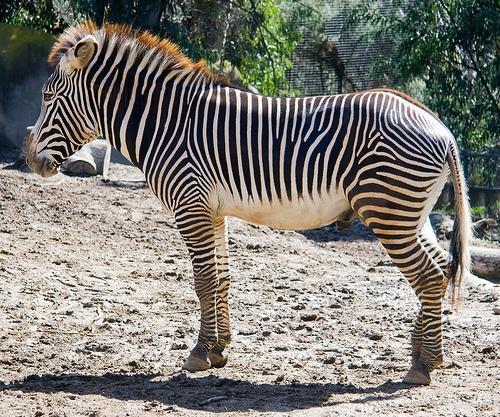How many zebras are in the picture?
Give a very brief answer. 1. How many legs does the zebra have?
Give a very brief answer. 4. 